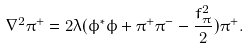<formula> <loc_0><loc_0><loc_500><loc_500>\nabla ^ { 2 } \pi ^ { + } = 2 \lambda ( \phi ^ { * } \phi + \pi ^ { + } \pi ^ { - } - \frac { f _ { \pi } ^ { 2 } } 2 ) \pi ^ { + } .</formula> 